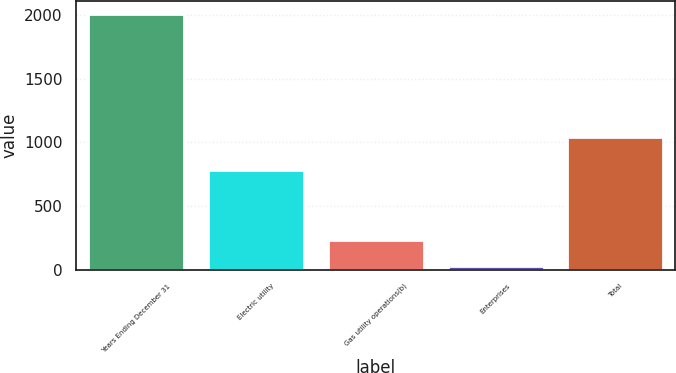Convert chart. <chart><loc_0><loc_0><loc_500><loc_500><bar_chart><fcel>Years Ending December 31<fcel>Electric utility<fcel>Gas utility operations(b)<fcel>Enterprises<fcel>Total<nl><fcel>2010<fcel>783<fcel>232<fcel>26<fcel>1041<nl></chart> 